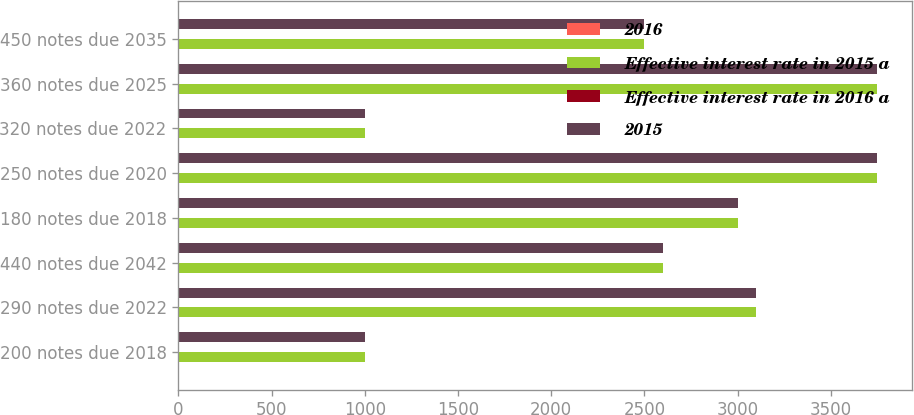<chart> <loc_0><loc_0><loc_500><loc_500><stacked_bar_chart><ecel><fcel>200 notes due 2018<fcel>290 notes due 2022<fcel>440 notes due 2042<fcel>180 notes due 2018<fcel>250 notes due 2020<fcel>320 notes due 2022<fcel>360 notes due 2025<fcel>450 notes due 2035<nl><fcel>2016<fcel>2.15<fcel>2.97<fcel>4.46<fcel>1.92<fcel>2.65<fcel>3.28<fcel>3.66<fcel>4.58<nl><fcel>Effective interest rate in 2015 a<fcel>1000<fcel>3100<fcel>2600<fcel>3000<fcel>3750<fcel>1000<fcel>3750<fcel>2500<nl><fcel>Effective interest rate in 2016 a<fcel>2.15<fcel>2.97<fcel>4.46<fcel>1.92<fcel>2.65<fcel>3.28<fcel>3.66<fcel>4.58<nl><fcel>2015<fcel>1000<fcel>3100<fcel>2600<fcel>3000<fcel>3750<fcel>1000<fcel>3750<fcel>2500<nl></chart> 